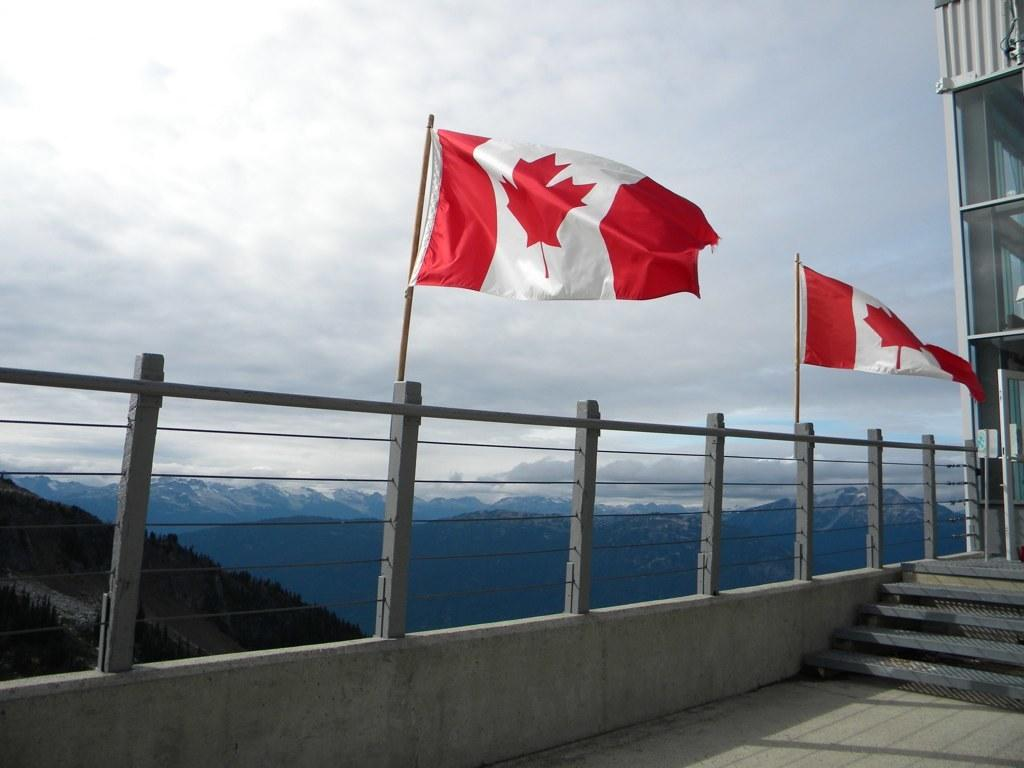What can be seen in the image that represents a symbol or country? There are flags in the image. What architectural feature is present in the image? There is railing and stairs in the image. What can be observed in relation to lighting in the image? Shadows are visible in the image. What natural features are visible in the background of the image? There are mountains, clouds, and the sky visible in the background of the image. What type of cent can be seen performing an act in the image? There is no cent or act present in the image. What sound can be heard from the bells in the image? There are no bells present in the image, so no sound can be heard. 